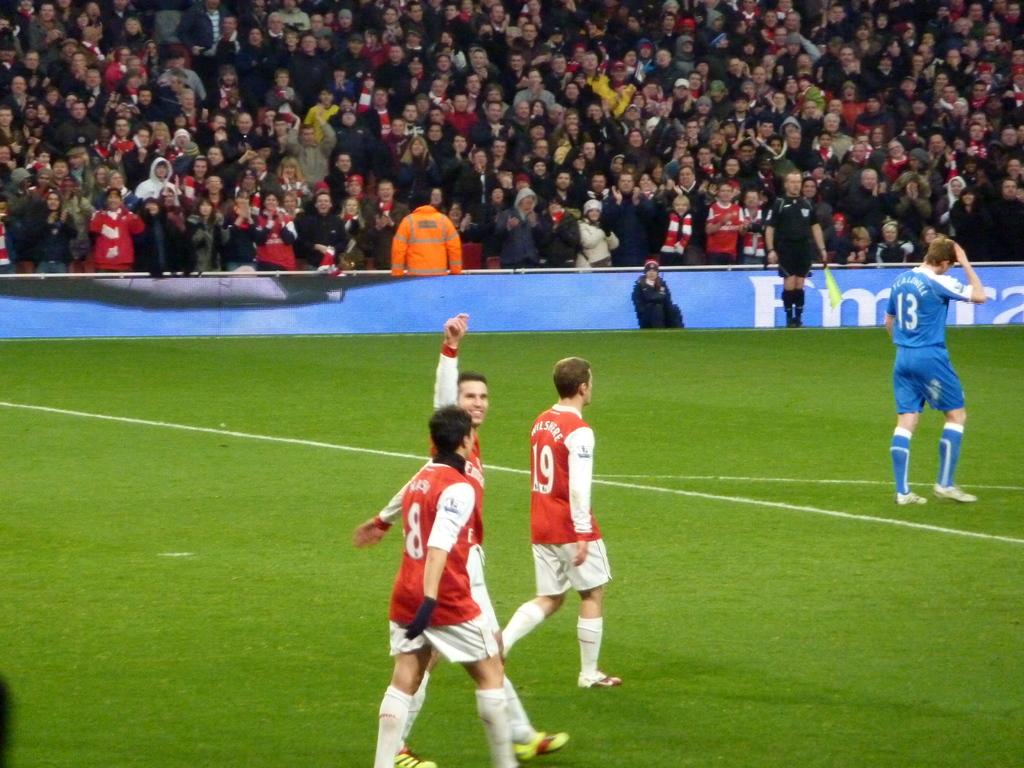<image>
Relay a brief, clear account of the picture shown. Soccer players in a stadium wearing jerseys with the numbers 8, 19, and 13. 